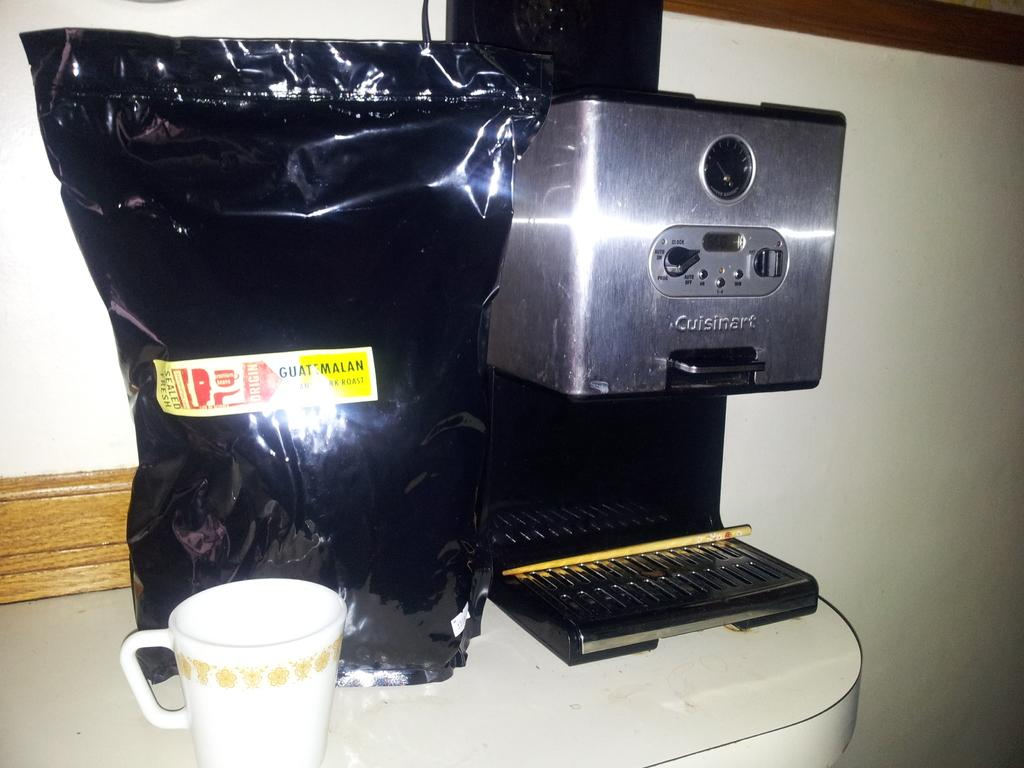<image>
Offer a succinct explanation of the picture presented. A bag of coffee states that it is Guatemalan. 